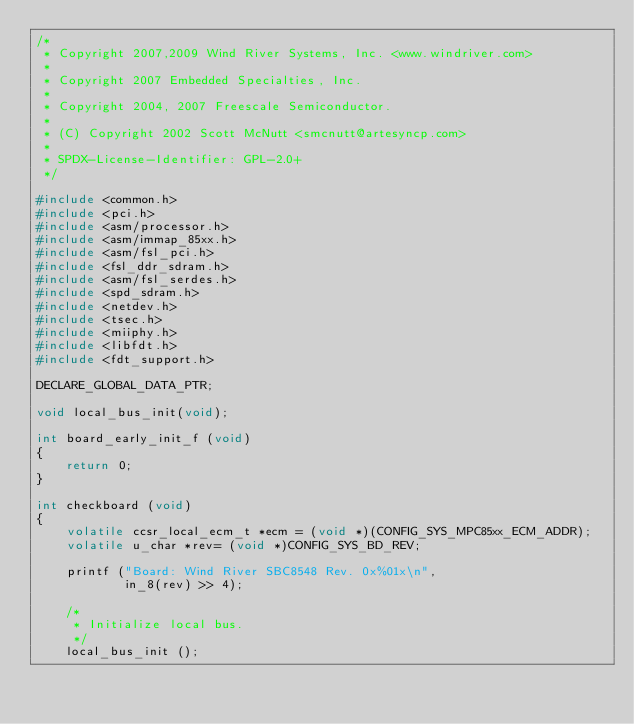<code> <loc_0><loc_0><loc_500><loc_500><_C_>/*
 * Copyright 2007,2009 Wind River Systems, Inc. <www.windriver.com>
 *
 * Copyright 2007 Embedded Specialties, Inc.
 *
 * Copyright 2004, 2007 Freescale Semiconductor.
 *
 * (C) Copyright 2002 Scott McNutt <smcnutt@artesyncp.com>
 *
 * SPDX-License-Identifier:	GPL-2.0+
 */

#include <common.h>
#include <pci.h>
#include <asm/processor.h>
#include <asm/immap_85xx.h>
#include <asm/fsl_pci.h>
#include <fsl_ddr_sdram.h>
#include <asm/fsl_serdes.h>
#include <spd_sdram.h>
#include <netdev.h>
#include <tsec.h>
#include <miiphy.h>
#include <libfdt.h>
#include <fdt_support.h>

DECLARE_GLOBAL_DATA_PTR;

void local_bus_init(void);

int board_early_init_f (void)
{
	return 0;
}

int checkboard (void)
{
	volatile ccsr_local_ecm_t *ecm = (void *)(CONFIG_SYS_MPC85xx_ECM_ADDR);
	volatile u_char *rev= (void *)CONFIG_SYS_BD_REV;

	printf ("Board: Wind River SBC8548 Rev. 0x%01x\n",
			in_8(rev) >> 4);

	/*
	 * Initialize local bus.
	 */
	local_bus_init ();
</code> 